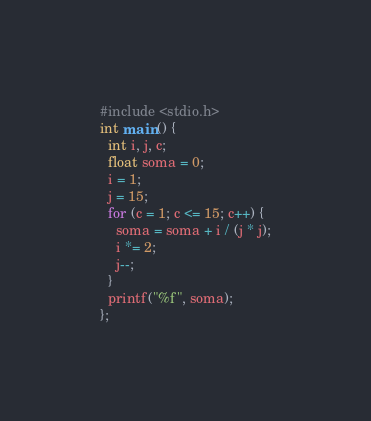<code> <loc_0><loc_0><loc_500><loc_500><_C_>#include <stdio.h>
int main() {
  int i, j, c;
  float soma = 0;
  i = 1;
  j = 15;
  for (c = 1; c <= 15; c++) {
    soma = soma + i / (j * j);
    i *= 2;
    j--;
  }
  printf("%f", soma);
};
</code> 